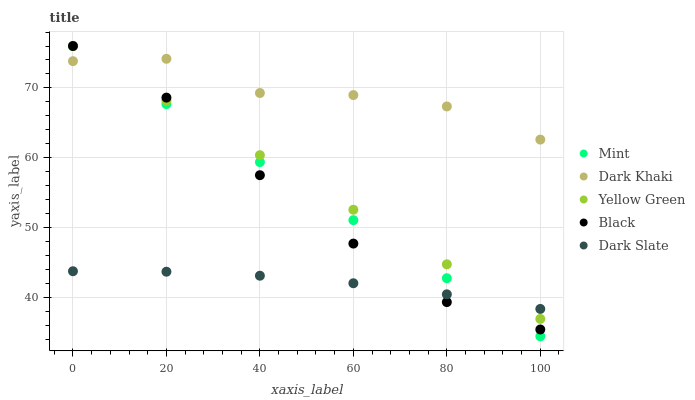Does Dark Slate have the minimum area under the curve?
Answer yes or no. Yes. Does Dark Khaki have the maximum area under the curve?
Answer yes or no. Yes. Does Black have the minimum area under the curve?
Answer yes or no. No. Does Black have the maximum area under the curve?
Answer yes or no. No. Is Mint the smoothest?
Answer yes or no. Yes. Is Dark Khaki the roughest?
Answer yes or no. Yes. Is Black the smoothest?
Answer yes or no. No. Is Black the roughest?
Answer yes or no. No. Does Mint have the lowest value?
Answer yes or no. Yes. Does Black have the lowest value?
Answer yes or no. No. Does Yellow Green have the highest value?
Answer yes or no. Yes. Does Dark Slate have the highest value?
Answer yes or no. No. Is Dark Slate less than Dark Khaki?
Answer yes or no. Yes. Is Dark Khaki greater than Dark Slate?
Answer yes or no. Yes. Does Black intersect Dark Khaki?
Answer yes or no. Yes. Is Black less than Dark Khaki?
Answer yes or no. No. Is Black greater than Dark Khaki?
Answer yes or no. No. Does Dark Slate intersect Dark Khaki?
Answer yes or no. No. 